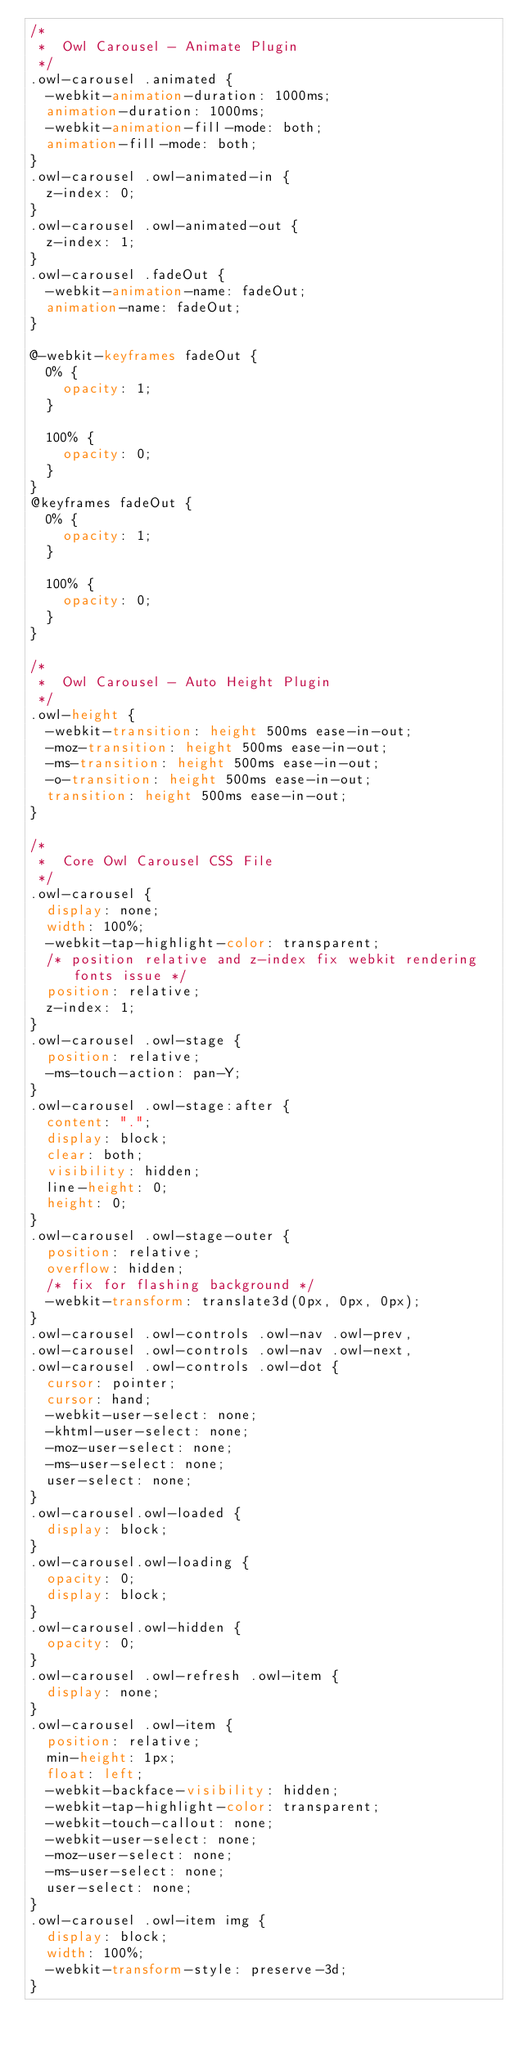<code> <loc_0><loc_0><loc_500><loc_500><_CSS_>/* 
 *  Owl Carousel - Animate Plugin
 */
.owl-carousel .animated {
  -webkit-animation-duration: 1000ms;
  animation-duration: 1000ms;
  -webkit-animation-fill-mode: both;
  animation-fill-mode: both;
}
.owl-carousel .owl-animated-in {
  z-index: 0;
}
.owl-carousel .owl-animated-out {
  z-index: 1;
}
.owl-carousel .fadeOut {
  -webkit-animation-name: fadeOut;
  animation-name: fadeOut;
}

@-webkit-keyframes fadeOut {
  0% {
    opacity: 1;
  }

  100% {
    opacity: 0;
  }
}
@keyframes fadeOut {
  0% {
    opacity: 1;
  }

  100% {
    opacity: 0;
  }
}

/* 
 * 	Owl Carousel - Auto Height Plugin
 */
.owl-height {
  -webkit-transition: height 500ms ease-in-out;
  -moz-transition: height 500ms ease-in-out;
  -ms-transition: height 500ms ease-in-out;
  -o-transition: height 500ms ease-in-out;
  transition: height 500ms ease-in-out;
}

/* 
 *  Core Owl Carousel CSS File
 */
.owl-carousel {
  display: none;
  width: 100%;
  -webkit-tap-highlight-color: transparent;
  /* position relative and z-index fix webkit rendering fonts issue */
  position: relative;
  z-index: 1;
}
.owl-carousel .owl-stage {
  position: relative;
  -ms-touch-action: pan-Y;
}
.owl-carousel .owl-stage:after {
  content: ".";
  display: block;
  clear: both;
  visibility: hidden;
  line-height: 0;
  height: 0;
}
.owl-carousel .owl-stage-outer {
  position: relative;
  overflow: hidden;
  /* fix for flashing background */
  -webkit-transform: translate3d(0px, 0px, 0px);
}
.owl-carousel .owl-controls .owl-nav .owl-prev,
.owl-carousel .owl-controls .owl-nav .owl-next,
.owl-carousel .owl-controls .owl-dot {
  cursor: pointer;
  cursor: hand;
  -webkit-user-select: none;
  -khtml-user-select: none;
  -moz-user-select: none;
  -ms-user-select: none;
  user-select: none;
}
.owl-carousel.owl-loaded {
  display: block;
}
.owl-carousel.owl-loading {
  opacity: 0;
  display: block;
}
.owl-carousel.owl-hidden {
  opacity: 0;
}
.owl-carousel .owl-refresh .owl-item {
  display: none;
}
.owl-carousel .owl-item {
  position: relative;
  min-height: 1px;
  float: left;
  -webkit-backface-visibility: hidden;
  -webkit-tap-highlight-color: transparent;
  -webkit-touch-callout: none;
  -webkit-user-select: none;
  -moz-user-select: none;
  -ms-user-select: none;
  user-select: none;
}
.owl-carousel .owl-item img {
  display: block;
  width: 100%;
  -webkit-transform-style: preserve-3d;
}</code> 